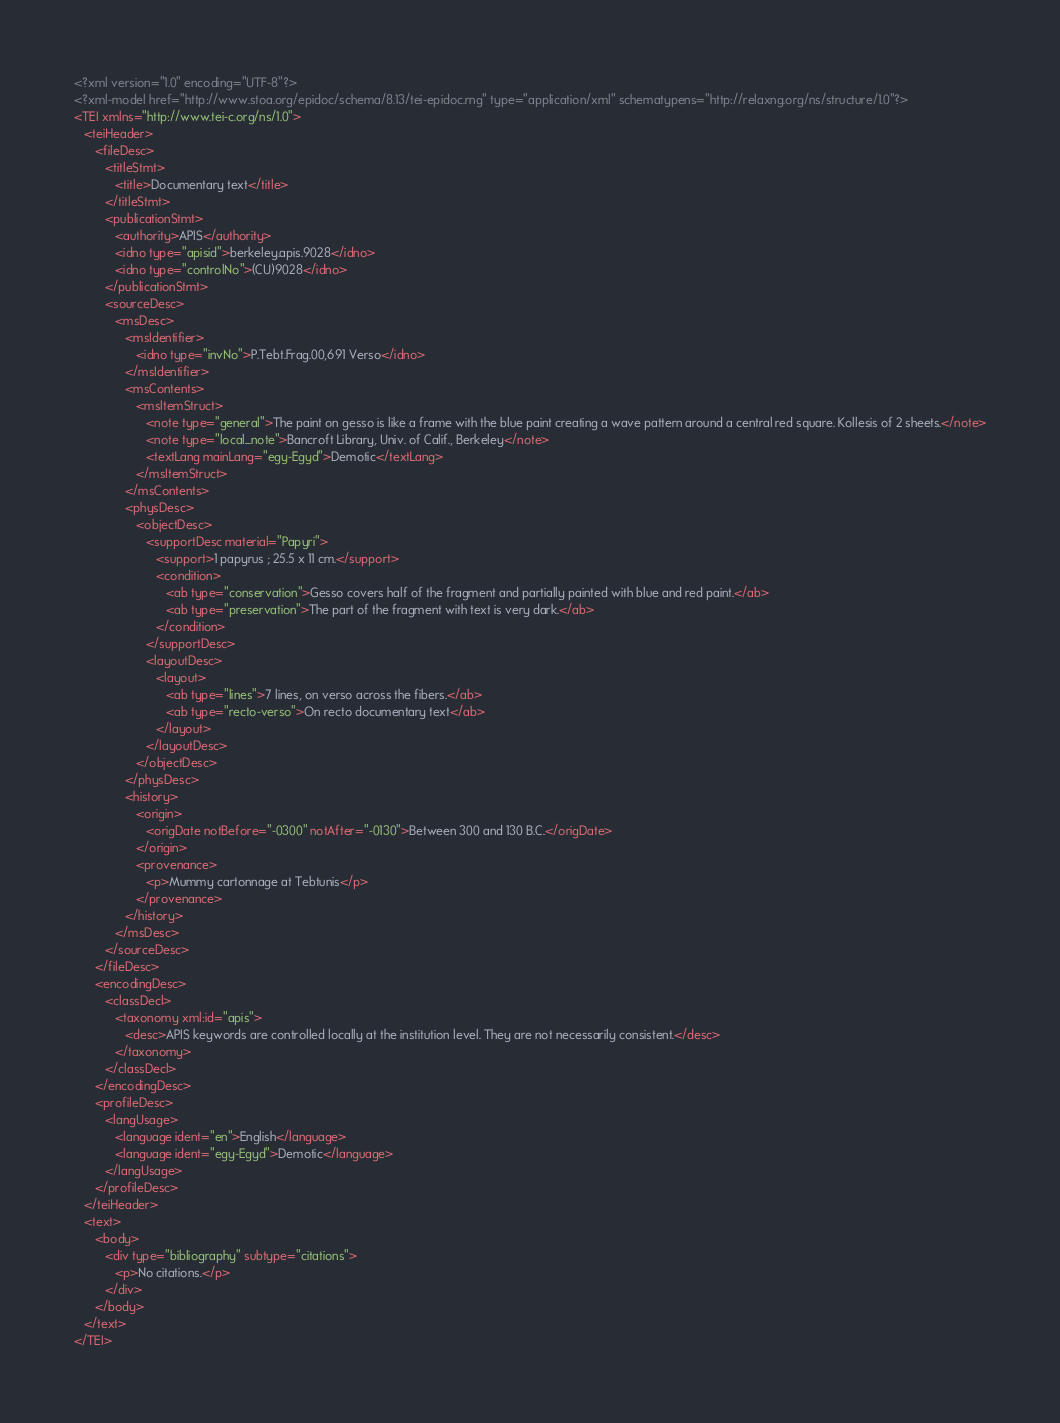<code> <loc_0><loc_0><loc_500><loc_500><_XML_><?xml version="1.0" encoding="UTF-8"?>
<?xml-model href="http://www.stoa.org/epidoc/schema/8.13/tei-epidoc.rng" type="application/xml" schematypens="http://relaxng.org/ns/structure/1.0"?>
<TEI xmlns="http://www.tei-c.org/ns/1.0">
   <teiHeader>
      <fileDesc>
         <titleStmt>
            <title>Documentary text</title>
         </titleStmt>
         <publicationStmt>
            <authority>APIS</authority>
            <idno type="apisid">berkeley.apis.9028</idno>
            <idno type="controlNo">(CU)9028</idno>
         </publicationStmt>
         <sourceDesc>
            <msDesc>
               <msIdentifier>
                  <idno type="invNo">P.Tebt.Frag.00,691 Verso</idno>
               </msIdentifier>
               <msContents>
                  <msItemStruct>
                     <note type="general">The paint on gesso is like a frame with the blue paint creating a wave pattern around a central red square. Kollesis of 2 sheets.</note>
                     <note type="local_note">Bancroft Library, Univ. of Calif., Berkeley</note>
                     <textLang mainLang="egy-Egyd">Demotic</textLang>
                  </msItemStruct>
               </msContents>
               <physDesc>
                  <objectDesc>
                     <supportDesc material="Papyri">
                        <support>1 papyrus ; 25.5 x 11 cm.</support>
                        <condition>
                           <ab type="conservation">Gesso covers half of the fragment and partially painted with blue and red paint.</ab>
                           <ab type="preservation">The part of the fragment with text is very dark.</ab>
                        </condition>
                     </supportDesc>
                     <layoutDesc>
                        <layout>
                           <ab type="lines">7 lines, on verso across the fibers.</ab>
                           <ab type="recto-verso">On recto documentary text</ab>
                        </layout>
                     </layoutDesc>
                  </objectDesc>
               </physDesc>
               <history>
                  <origin>
                     <origDate notBefore="-0300" notAfter="-0130">Between 300 and 130 B.C.</origDate>
                  </origin>
                  <provenance>
                     <p>Mummy cartonnage at Tebtunis</p>
                  </provenance>
               </history>
            </msDesc>
         </sourceDesc>
      </fileDesc>
      <encodingDesc>
         <classDecl>
            <taxonomy xml:id="apis">
               <desc>APIS keywords are controlled locally at the institution level. They are not necessarily consistent.</desc>
            </taxonomy>
         </classDecl>
      </encodingDesc>
      <profileDesc>
         <langUsage>
            <language ident="en">English</language>
            <language ident="egy-Egyd">Demotic</language>
         </langUsage>
      </profileDesc>
   </teiHeader>
   <text>
      <body>
         <div type="bibliography" subtype="citations">
            <p>No citations.</p>
         </div>
      </body>
   </text>
</TEI></code> 